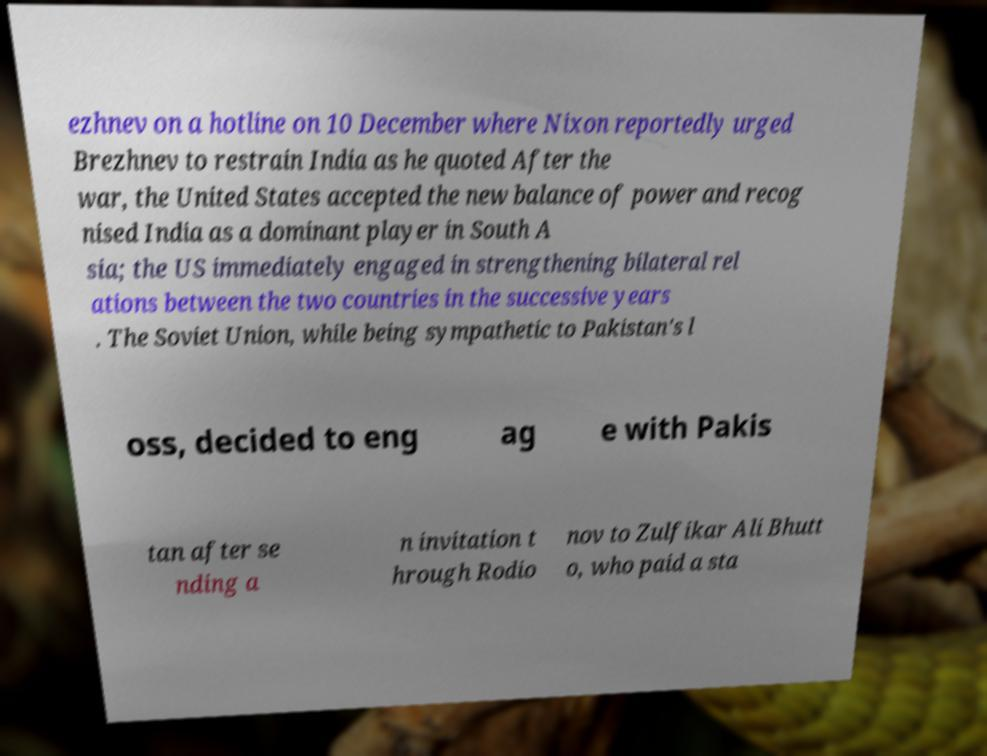Could you assist in decoding the text presented in this image and type it out clearly? ezhnev on a hotline on 10 December where Nixon reportedly urged Brezhnev to restrain India as he quoted After the war, the United States accepted the new balance of power and recog nised India as a dominant player in South A sia; the US immediately engaged in strengthening bilateral rel ations between the two countries in the successive years . The Soviet Union, while being sympathetic to Pakistan's l oss, decided to eng ag e with Pakis tan after se nding a n invitation t hrough Rodio nov to Zulfikar Ali Bhutt o, who paid a sta 